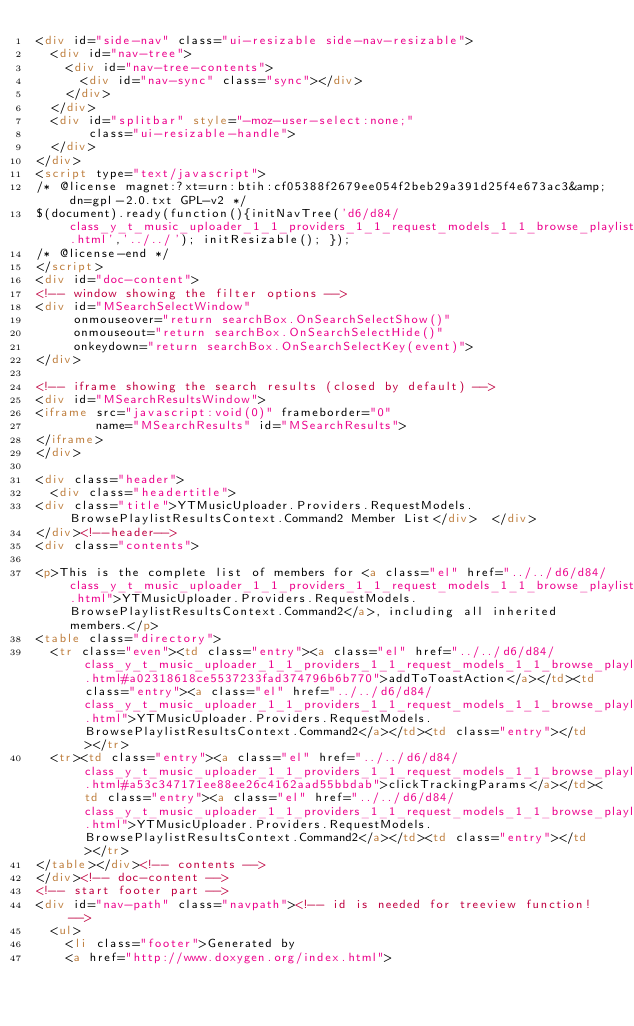Convert code to text. <code><loc_0><loc_0><loc_500><loc_500><_HTML_><div id="side-nav" class="ui-resizable side-nav-resizable">
  <div id="nav-tree">
    <div id="nav-tree-contents">
      <div id="nav-sync" class="sync"></div>
    </div>
  </div>
  <div id="splitbar" style="-moz-user-select:none;" 
       class="ui-resizable-handle">
  </div>
</div>
<script type="text/javascript">
/* @license magnet:?xt=urn:btih:cf05388f2679ee054f2beb29a391d25f4e673ac3&amp;dn=gpl-2.0.txt GPL-v2 */
$(document).ready(function(){initNavTree('d6/d84/class_y_t_music_uploader_1_1_providers_1_1_request_models_1_1_browse_playlist_results_context_1_1_command2.html','../../'); initResizable(); });
/* @license-end */
</script>
<div id="doc-content">
<!-- window showing the filter options -->
<div id="MSearchSelectWindow"
     onmouseover="return searchBox.OnSearchSelectShow()"
     onmouseout="return searchBox.OnSearchSelectHide()"
     onkeydown="return searchBox.OnSearchSelectKey(event)">
</div>

<!-- iframe showing the search results (closed by default) -->
<div id="MSearchResultsWindow">
<iframe src="javascript:void(0)" frameborder="0" 
        name="MSearchResults" id="MSearchResults">
</iframe>
</div>

<div class="header">
  <div class="headertitle">
<div class="title">YTMusicUploader.Providers.RequestModels.BrowsePlaylistResultsContext.Command2 Member List</div>  </div>
</div><!--header-->
<div class="contents">

<p>This is the complete list of members for <a class="el" href="../../d6/d84/class_y_t_music_uploader_1_1_providers_1_1_request_models_1_1_browse_playlist_results_context_1_1_command2.html">YTMusicUploader.Providers.RequestModels.BrowsePlaylistResultsContext.Command2</a>, including all inherited members.</p>
<table class="directory">
  <tr class="even"><td class="entry"><a class="el" href="../../d6/d84/class_y_t_music_uploader_1_1_providers_1_1_request_models_1_1_browse_playlist_results_context_1_1_command2.html#a02318618ce5537233fad374796b6b770">addToToastAction</a></td><td class="entry"><a class="el" href="../../d6/d84/class_y_t_music_uploader_1_1_providers_1_1_request_models_1_1_browse_playlist_results_context_1_1_command2.html">YTMusicUploader.Providers.RequestModels.BrowsePlaylistResultsContext.Command2</a></td><td class="entry"></td></tr>
  <tr><td class="entry"><a class="el" href="../../d6/d84/class_y_t_music_uploader_1_1_providers_1_1_request_models_1_1_browse_playlist_results_context_1_1_command2.html#a53c347171ee88ee26c4162aad55bbdab">clickTrackingParams</a></td><td class="entry"><a class="el" href="../../d6/d84/class_y_t_music_uploader_1_1_providers_1_1_request_models_1_1_browse_playlist_results_context_1_1_command2.html">YTMusicUploader.Providers.RequestModels.BrowsePlaylistResultsContext.Command2</a></td><td class="entry"></td></tr>
</table></div><!-- contents -->
</div><!-- doc-content -->
<!-- start footer part -->
<div id="nav-path" class="navpath"><!-- id is needed for treeview function! -->
  <ul>
    <li class="footer">Generated by
    <a href="http://www.doxygen.org/index.html"></code> 